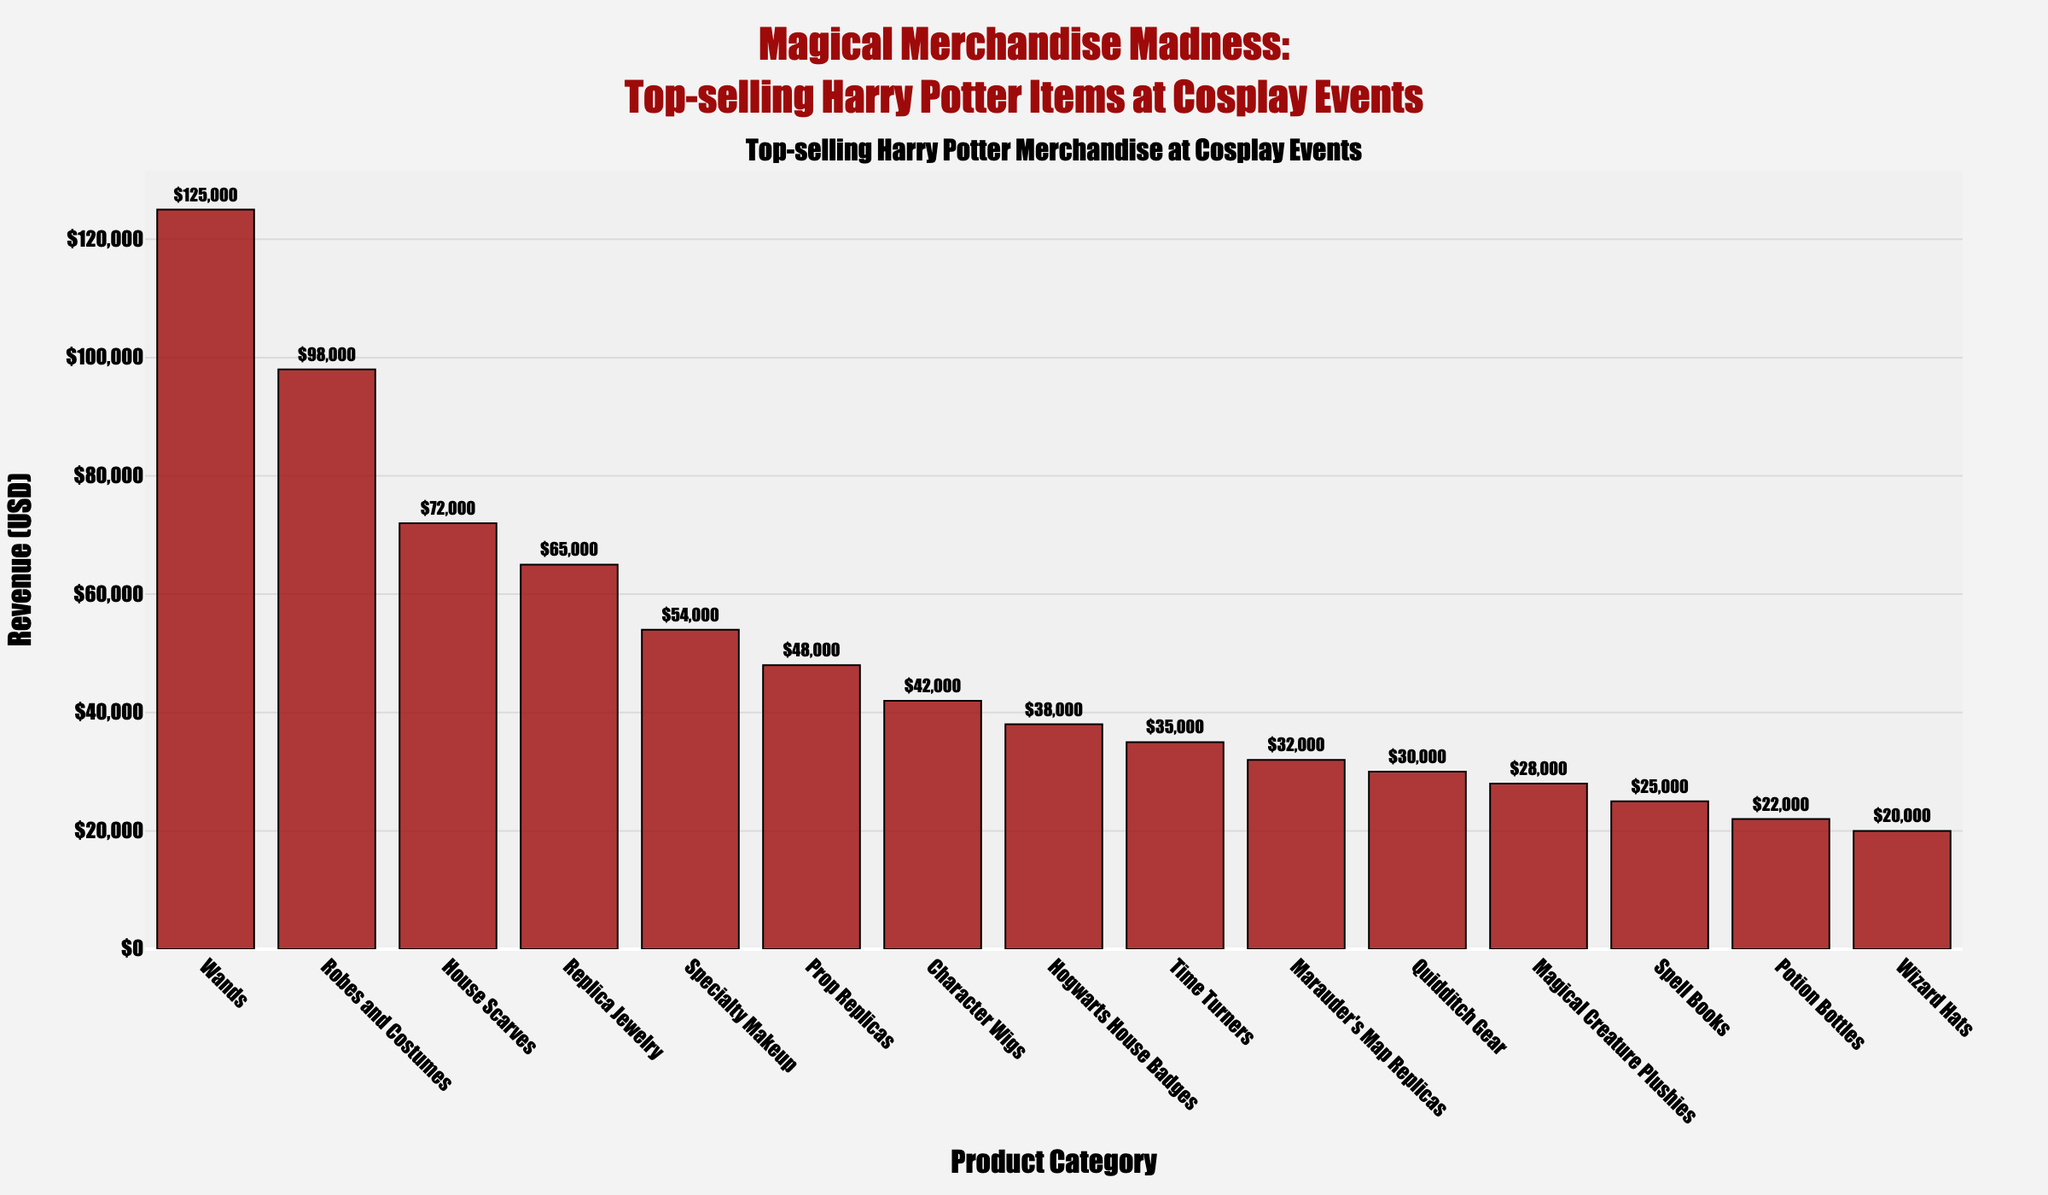What's the total revenue generated by the top three categories? First, identify the top three categories from the chart: Wands, Robes and Costumes, and House Scarves. Their revenues are $125,000, $98,000, and $72,000 respectively. Sum these values: $125,000 + $98,000 + $72,000 = $295,000.
Answer: $295,000 Which category has the highest revenue, and how much more does it generate compared to the lowest revenue category? The category with the highest revenue is Wands with $125,000. The category with the lowest revenue is Wizard Hats with $20,000. The difference in revenue is $125,000 - $20,000 = $105,000.
Answer: Wands, $105,000 What's the median revenue value across all categories? To find the median revenue, first list all revenues in ascending order: $20,000, $22,000, $25,000, $28,000, $30,000, $32,000, $35,000, $38,000, $42,000, $48,000, $54,000, $65,000, $72,000, $98,000, $125,000. The middle value in this sorted list of 15 numbers is the 8th value, which is $38,000.
Answer: $38,000 Are there more items generating revenue above or below the average revenue? First, calculate the average revenue. Sum all revenues ($1,013,000) and divide by the number of categories (15): $1,013,000 / 15 = approx. $67,533. Determine the number of categories above and below this value. Categories above: 4. Categories below: 11. There are more items generating revenue below the average.
Answer: Below How does the revenue of 'House Scarves' compare to 'Prop Replicas' and 'Character Wigs' combined? The revenue for House Scarves is $72,000. The combined revenue for Prop Replicas and Character Wigs is $48,000 + $42,000 = $90,000. Compare the two: $72,000 is less than $90,000.
Answer: Less What is the mean revenue excluding the top revenue category? Exclude the top category (Wands: $125,000) and sum the remaining revenues: $1,013,000 - $125,000 = $888,000. Divide by the remaining number of categories (14): $888,000 / 14 = approximately $63,429.
Answer: $63,429 What is the range of the revenue values shown in the chart? To find the range, take the highest revenue (Wands: $125,000) and subtract the lowest revenue (Wizard Hats: $20,000). Range = $125,000 - $20,000 = $105,000.
Answer: $105,000 